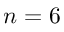<formula> <loc_0><loc_0><loc_500><loc_500>n = 6</formula> 